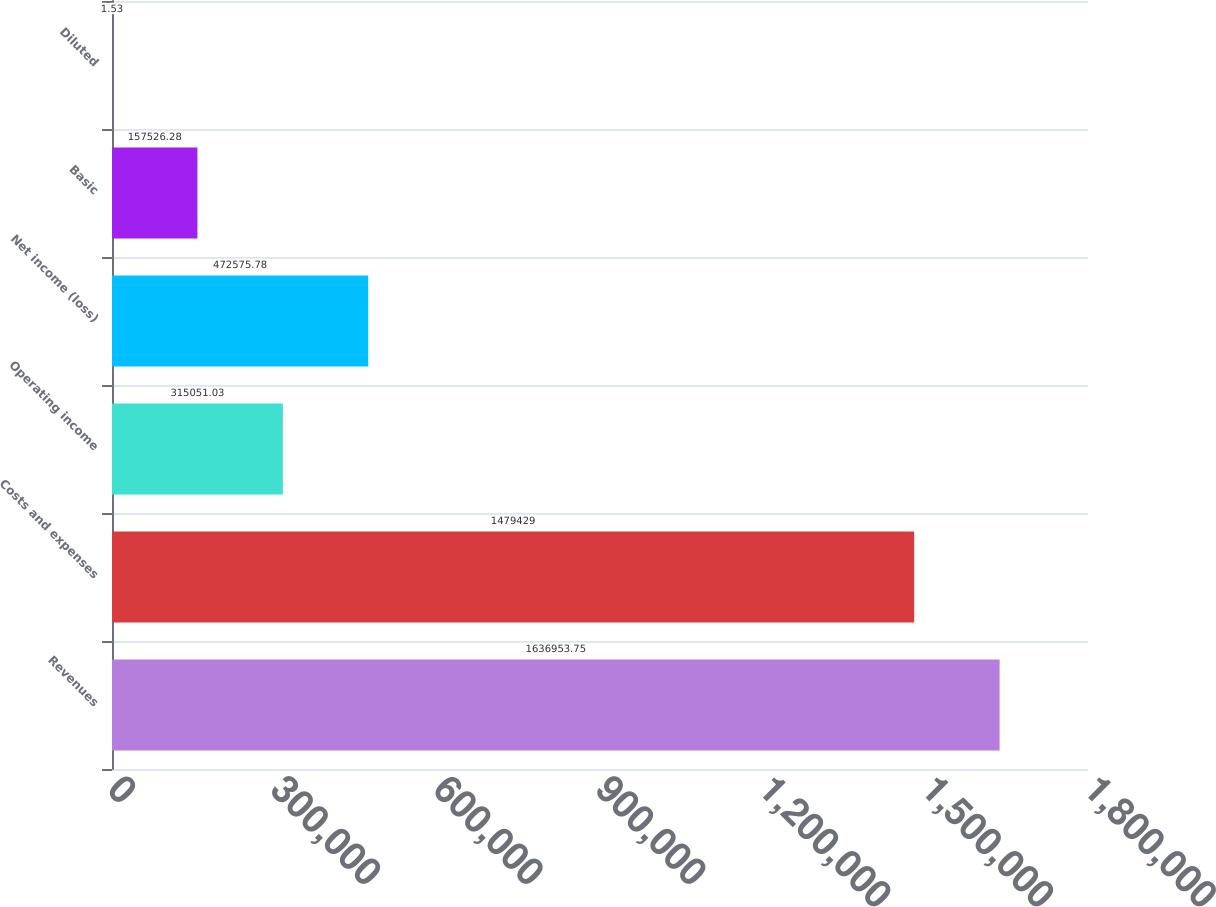Convert chart to OTSL. <chart><loc_0><loc_0><loc_500><loc_500><bar_chart><fcel>Revenues<fcel>Costs and expenses<fcel>Operating income<fcel>Net income (loss)<fcel>Basic<fcel>Diluted<nl><fcel>1.63695e+06<fcel>1.47943e+06<fcel>315051<fcel>472576<fcel>157526<fcel>1.53<nl></chart> 